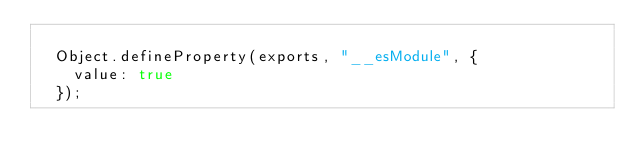<code> <loc_0><loc_0><loc_500><loc_500><_JavaScript_>
  Object.defineProperty(exports, "__esModule", {
    value: true
  });</code> 